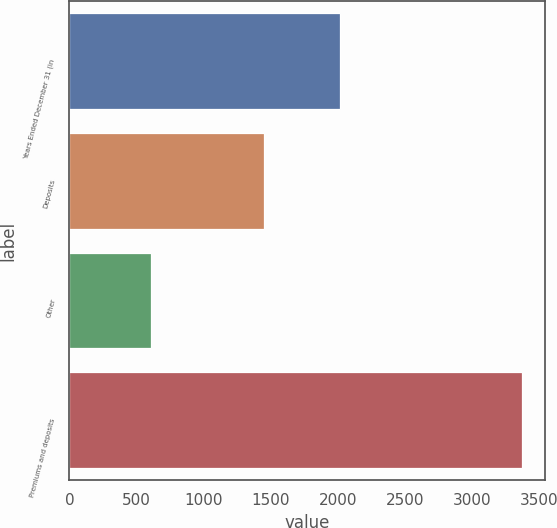Convert chart. <chart><loc_0><loc_0><loc_500><loc_500><bar_chart><fcel>Years Ended December 31 (in<fcel>Deposits<fcel>Other<fcel>Premiums and deposits<nl><fcel>2015<fcel>1451<fcel>608<fcel>3370<nl></chart> 